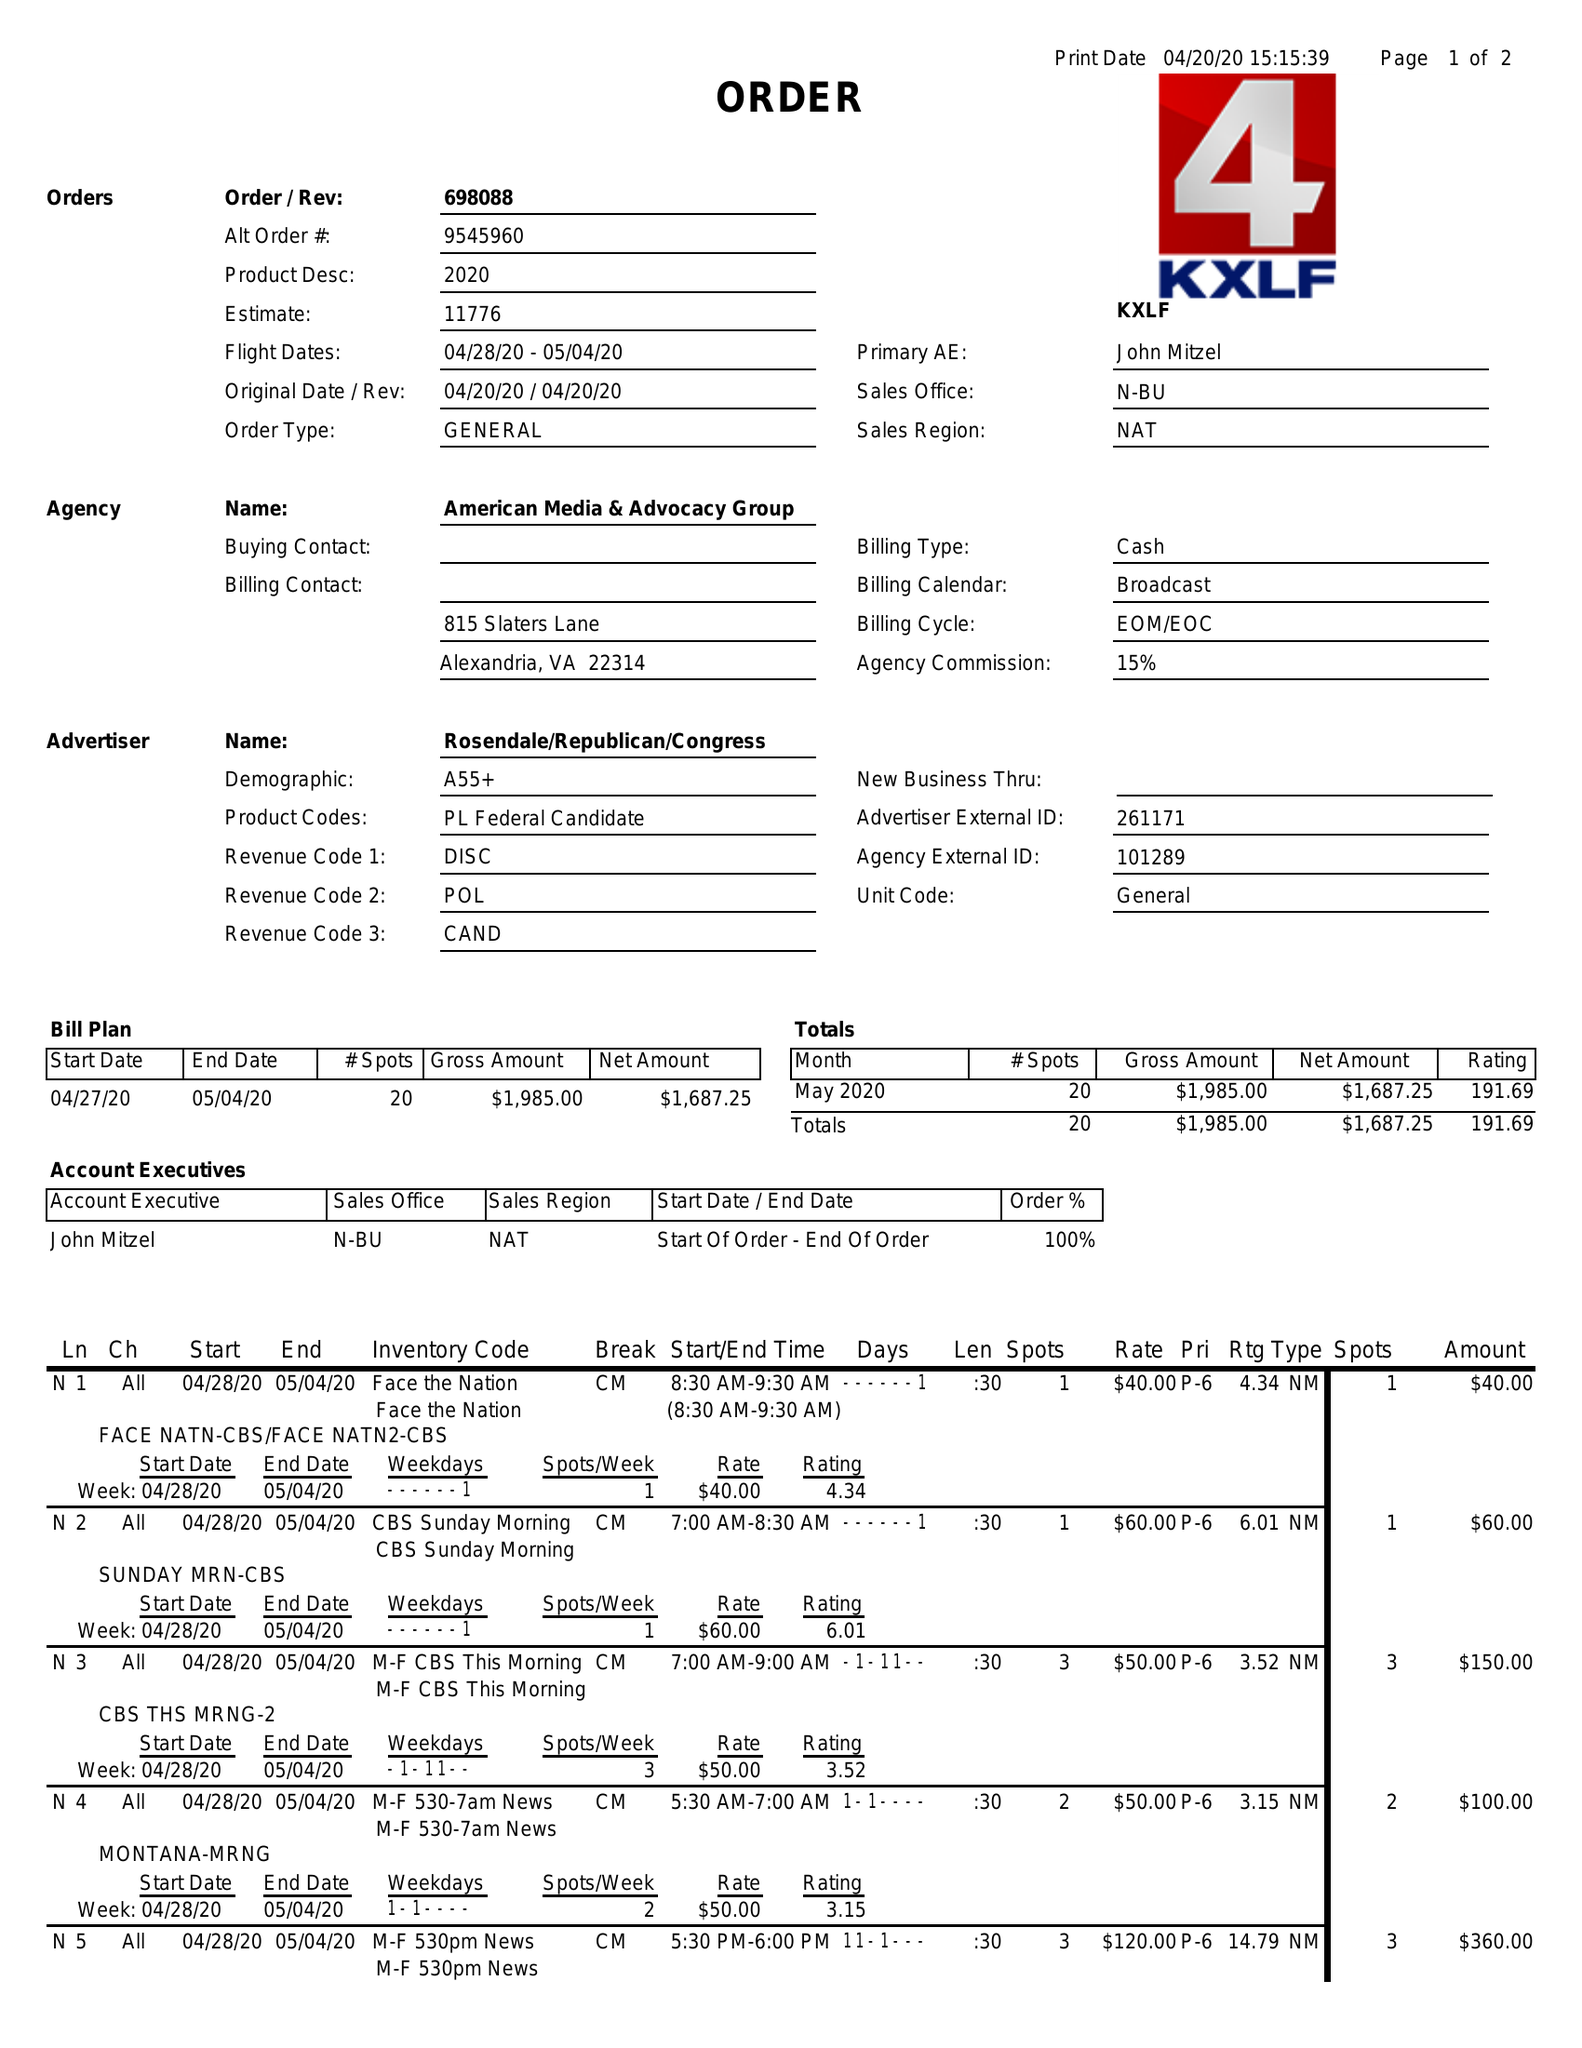What is the value for the flight_from?
Answer the question using a single word or phrase. 04/28/20 